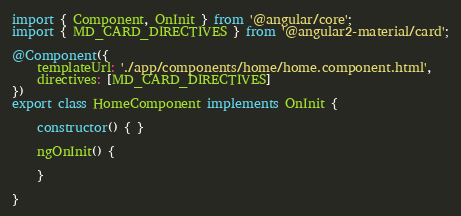<code> <loc_0><loc_0><loc_500><loc_500><_TypeScript_>import { Component, OnInit } from '@angular/core';
import { MD_CARD_DIRECTIVES } from '@angular2-material/card';

@Component({
    templateUrl: './app/components/home/home.component.html',
    directives: [MD_CARD_DIRECTIVES]
})
export class HomeComponent implements OnInit {

    constructor() { }

    ngOnInit() {

    }

}</code> 